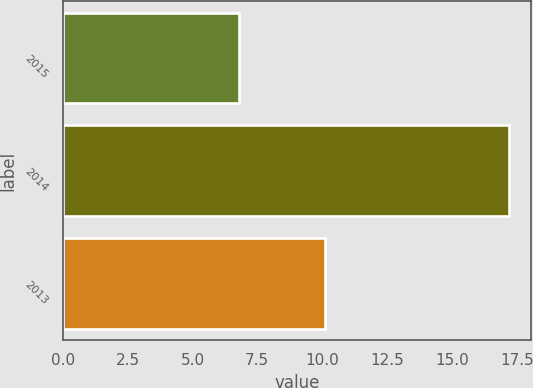Convert chart. <chart><loc_0><loc_0><loc_500><loc_500><bar_chart><fcel>2015<fcel>2014<fcel>2013<nl><fcel>6.8<fcel>17.2<fcel>10.1<nl></chart> 